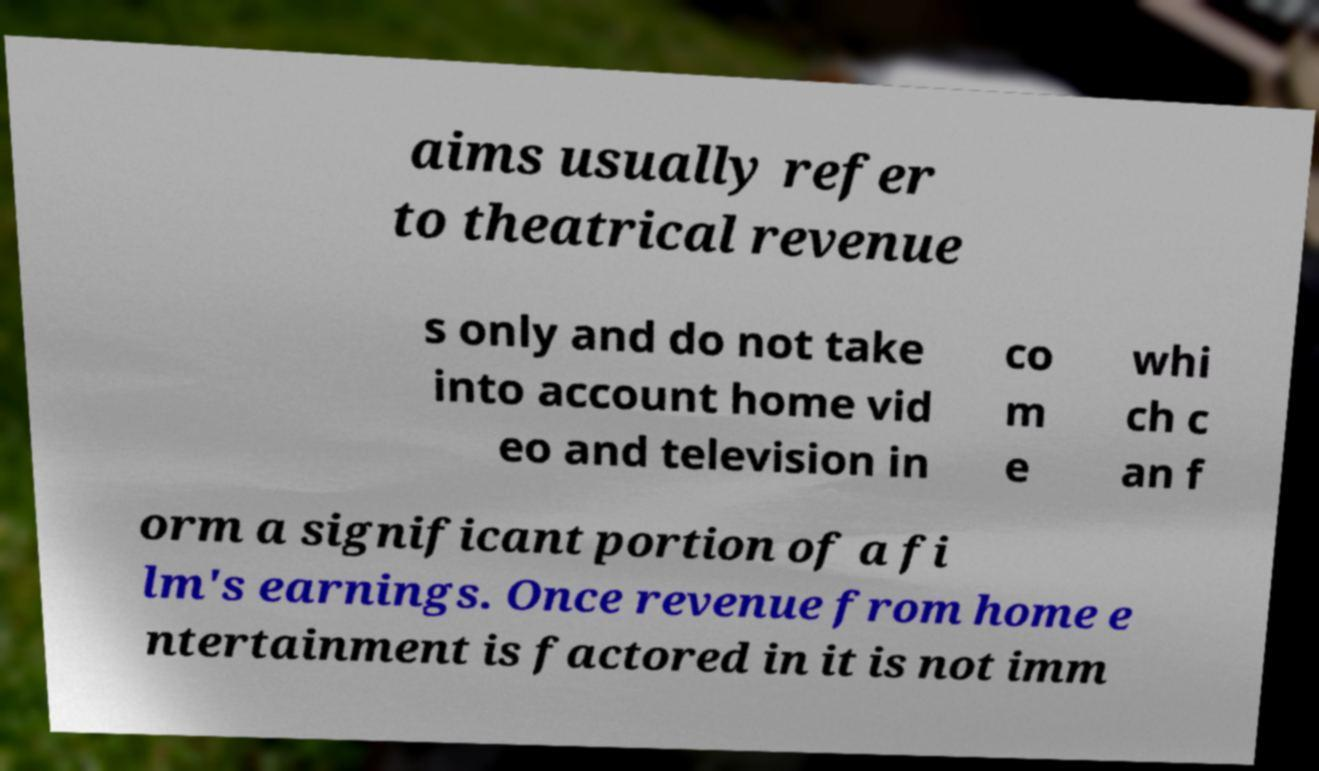Can you accurately transcribe the text from the provided image for me? aims usually refer to theatrical revenue s only and do not take into account home vid eo and television in co m e whi ch c an f orm a significant portion of a fi lm's earnings. Once revenue from home e ntertainment is factored in it is not imm 